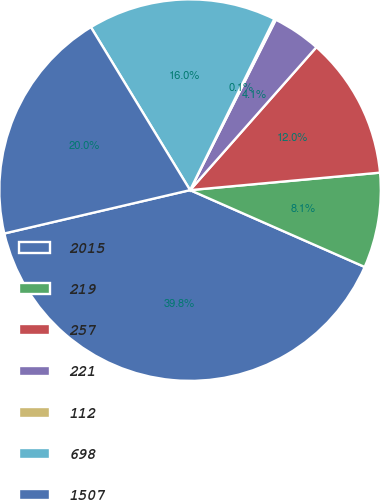Convert chart to OTSL. <chart><loc_0><loc_0><loc_500><loc_500><pie_chart><fcel>2015<fcel>219<fcel>257<fcel>221<fcel>112<fcel>698<fcel>1507<nl><fcel>39.75%<fcel>8.06%<fcel>12.02%<fcel>4.1%<fcel>0.14%<fcel>15.98%<fcel>19.95%<nl></chart> 